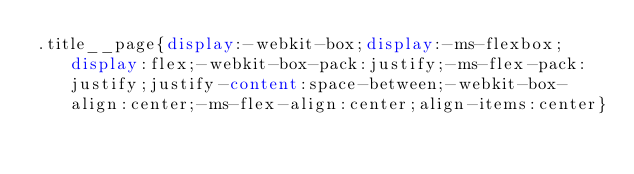Convert code to text. <code><loc_0><loc_0><loc_500><loc_500><_CSS_>.title__page{display:-webkit-box;display:-ms-flexbox;display:flex;-webkit-box-pack:justify;-ms-flex-pack:justify;justify-content:space-between;-webkit-box-align:center;-ms-flex-align:center;align-items:center}
</code> 